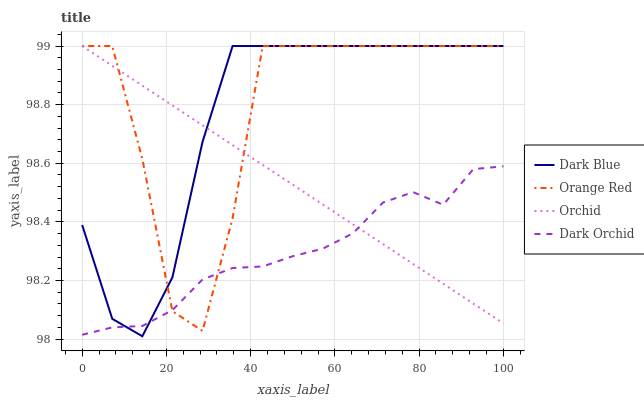Does Dark Orchid have the minimum area under the curve?
Answer yes or no. Yes. Does Orange Red have the minimum area under the curve?
Answer yes or no. No. Does Dark Orchid have the maximum area under the curve?
Answer yes or no. No. Is Orange Red the roughest?
Answer yes or no. Yes. Is Dark Orchid the smoothest?
Answer yes or no. No. Is Dark Orchid the roughest?
Answer yes or no. No. Does Orange Red have the lowest value?
Answer yes or no. No. Does Dark Orchid have the highest value?
Answer yes or no. No. 